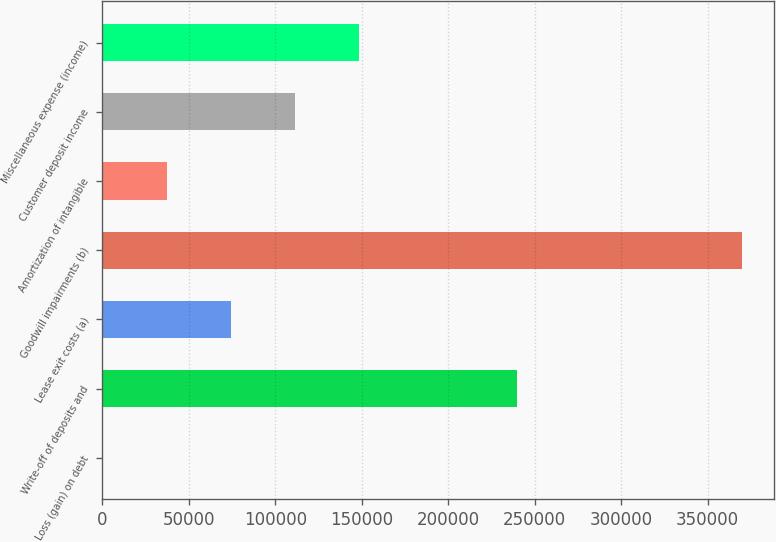Convert chart. <chart><loc_0><loc_0><loc_500><loc_500><bar_chart><fcel>Loss (gain) on debt<fcel>Write-off of deposits and<fcel>Lease exit costs (a)<fcel>Goodwill impairments (b)<fcel>Amortization of intangible<fcel>Customer deposit income<fcel>Miscellaneous expense (income)<nl><fcel>543<fcel>239716<fcel>74439<fcel>370023<fcel>37491<fcel>111387<fcel>148335<nl></chart> 